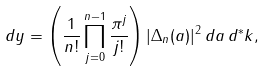Convert formula to latex. <formula><loc_0><loc_0><loc_500><loc_500>d y = \left ( \frac { 1 } { n ! } \prod _ { j = 0 } ^ { n - 1 } \frac { \pi ^ { j } } { j ! } \right ) | \Delta _ { n } ( a ) | ^ { 2 } \, d a \, d ^ { * } k ,</formula> 